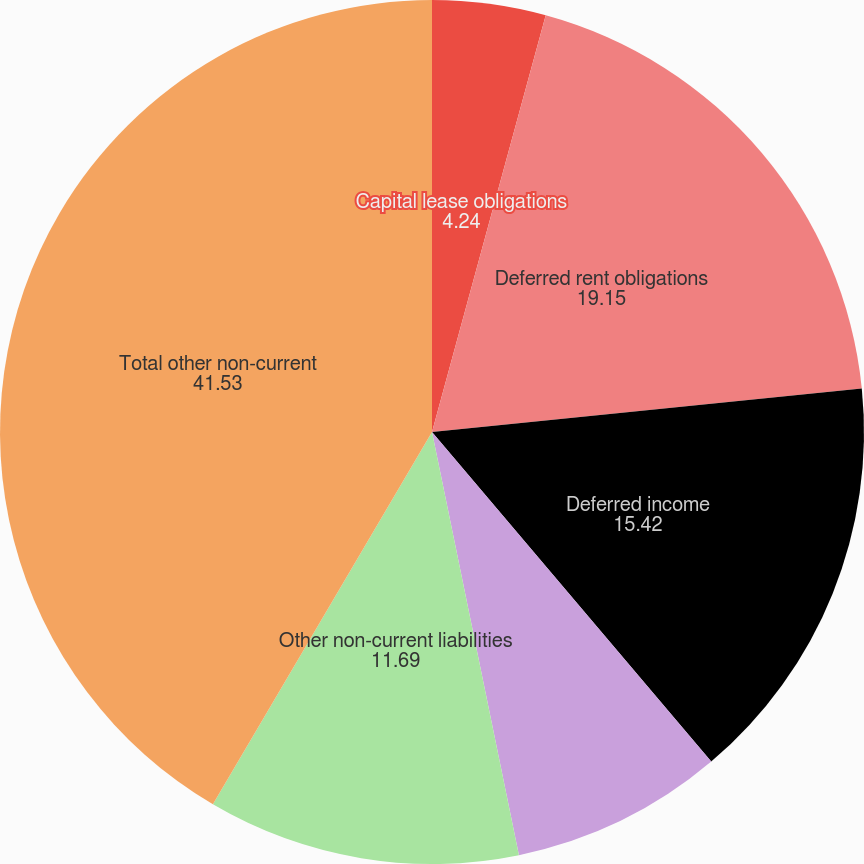<chart> <loc_0><loc_0><loc_500><loc_500><pie_chart><fcel>Capital lease obligations<fcel>Deferred rent obligations<fcel>Deferred income<fcel>Deferred tax liabilities<fcel>Other non-current liabilities<fcel>Total other non-current<nl><fcel>4.24%<fcel>19.15%<fcel>15.42%<fcel>7.96%<fcel>11.69%<fcel>41.53%<nl></chart> 